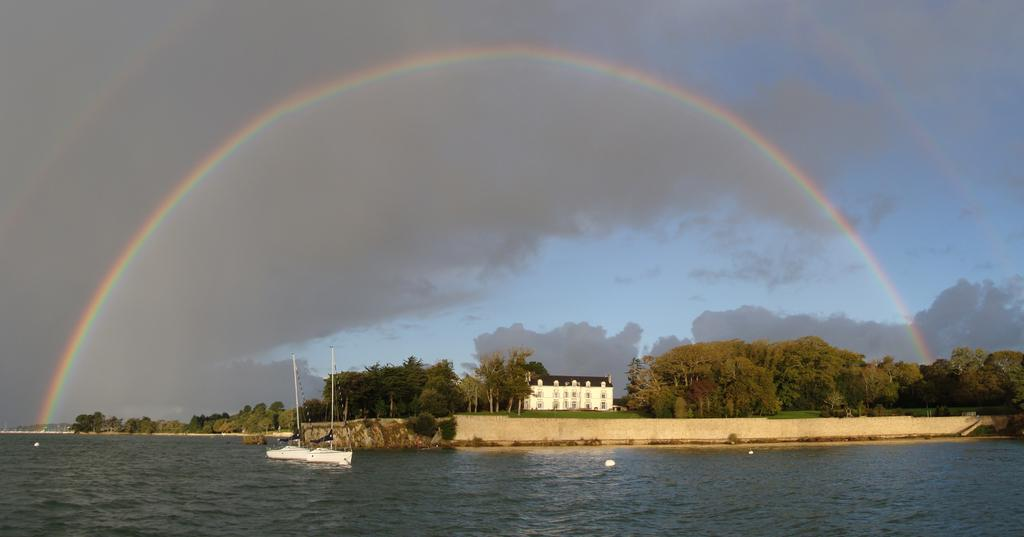What can be seen floating in the water in the image? There are ships in the water in the image. What structure is located in the center of the image? There is a house in the center of the image. What type of vegetation is visible in the background of the image? There are trees in the background of the image. What natural phenomenon can be seen in the background of the image? There is a rainbow visible in the background of the image. What else is visible in the background of the image? The sky is visible in the background of the image. What type of jewel can be seen in the image? There is no jewel present in the image. Is there a bone visible in the image? There is no bone present in the image. 